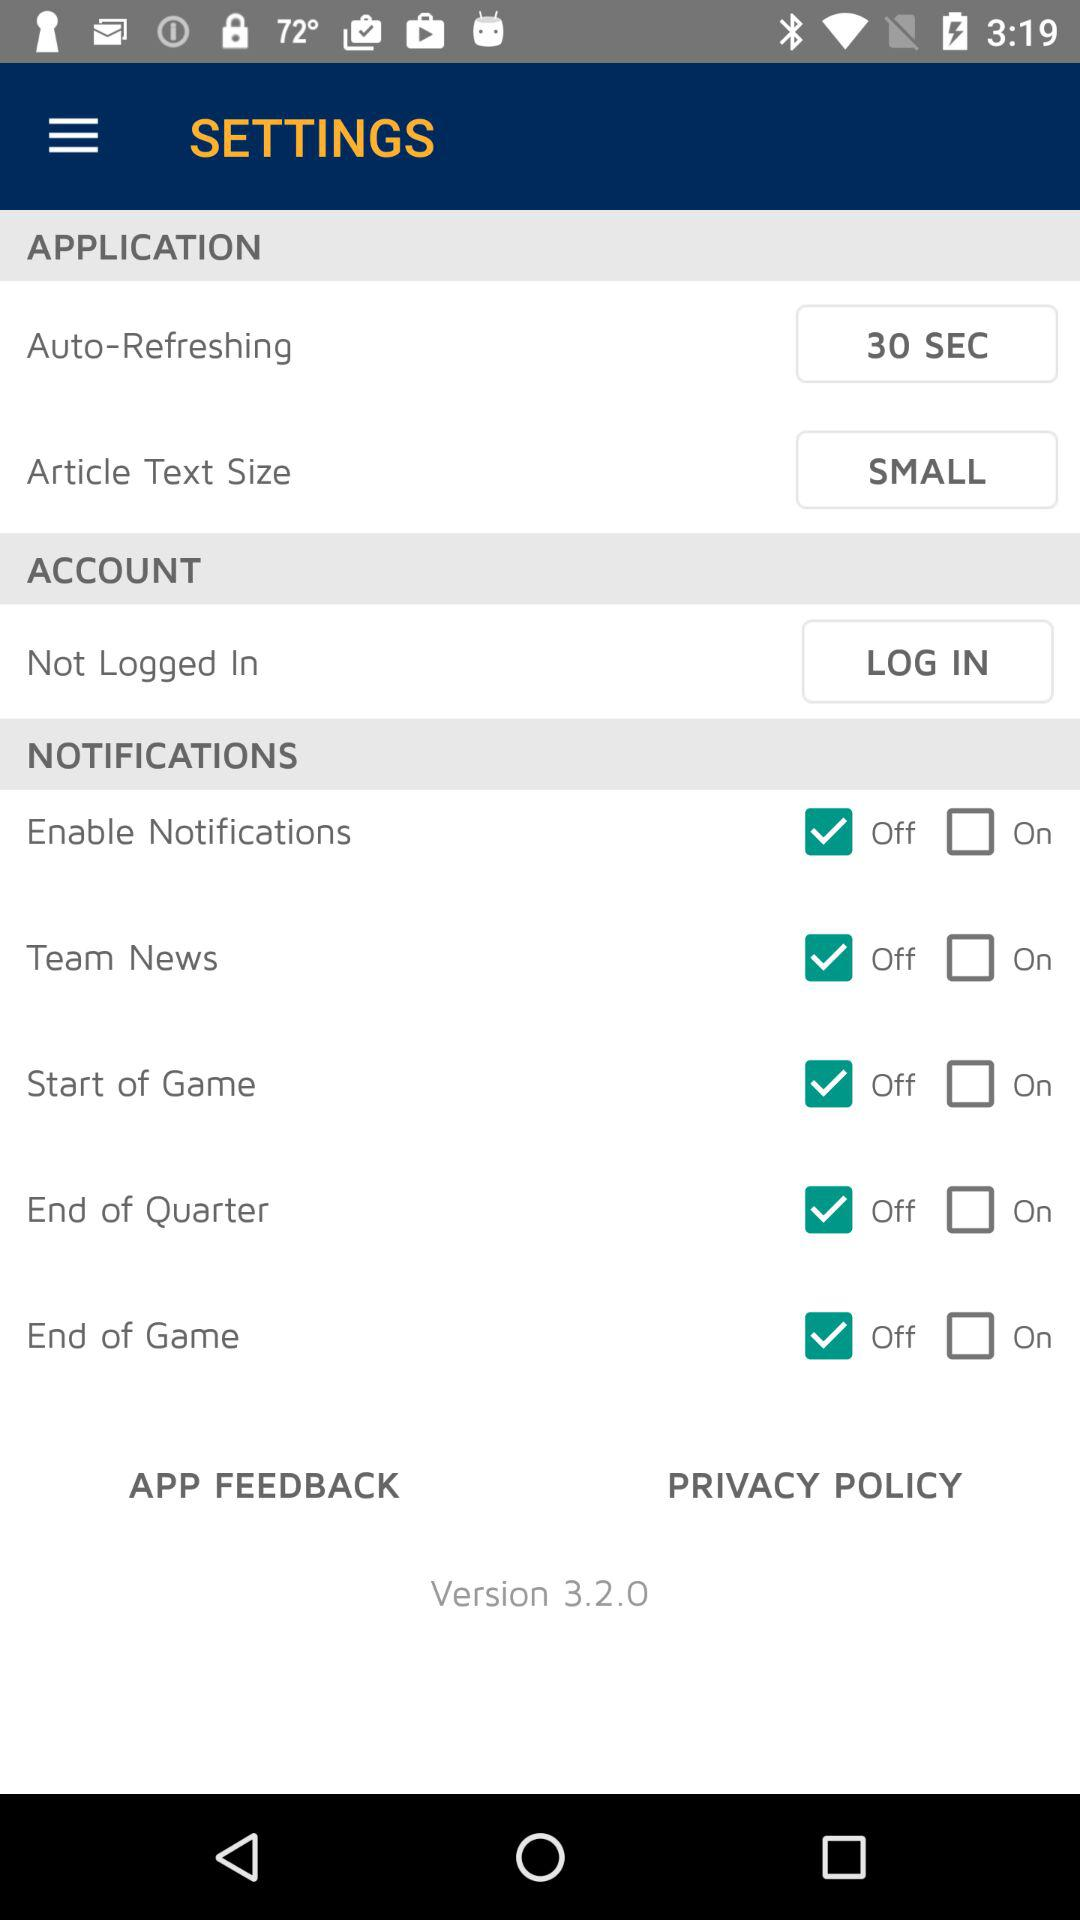What is the status of the "Start of Game" notification setting? The status is "off". 